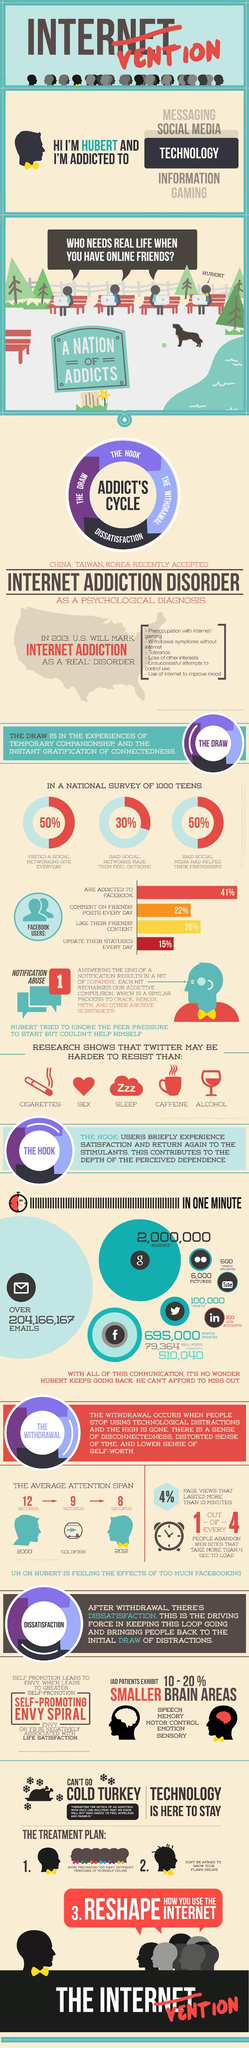Draw attention to some important aspects in this diagram. According to a national survey of 1000 teens, 30% of teens reported that social networks made them feel outgoing. According to the survey, an average of 510,040 Facebook comments were posted per minute. According to a survey, on average, 100 new LinkedIn accounts are created in every minute. According to a national survey of 1000 teens, 50% of the teens surveyed said that social media had helped their friendships. According to the survey, the number of Google searches done in one minute is approximately 2,000,000. 